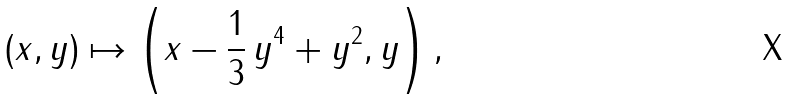<formula> <loc_0><loc_0><loc_500><loc_500>( x , y ) \mapsto \left ( x - \frac { 1 } { 3 } \, y ^ { 4 } + y ^ { 2 } , y \right ) ,</formula> 